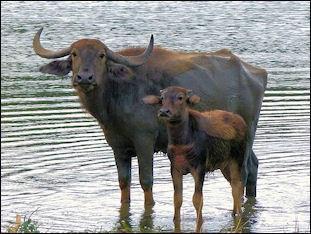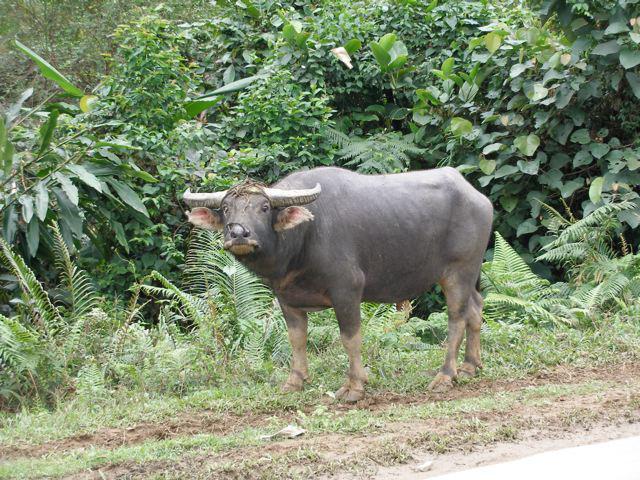The first image is the image on the left, the second image is the image on the right. Evaluate the accuracy of this statement regarding the images: "At least one image has more than one animal.". Is it true? Answer yes or no. Yes. 